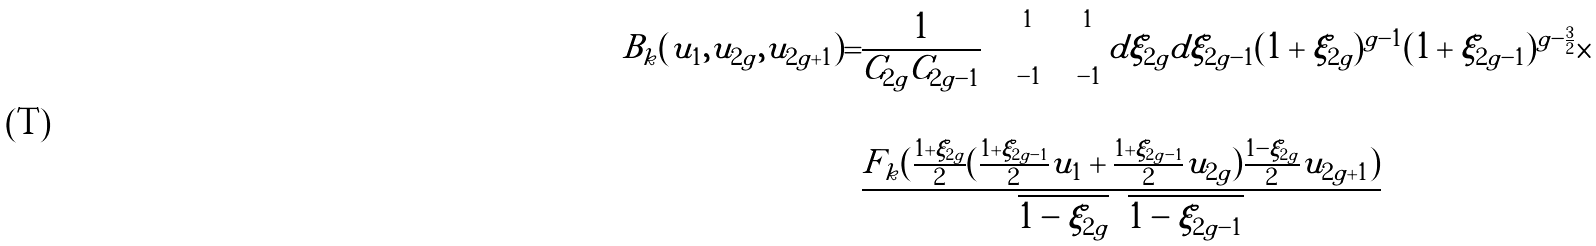<formula> <loc_0><loc_0><loc_500><loc_500>B _ { k } ( u _ { 1 } , u _ { 2 g } , u _ { 2 g + 1 } ) = & \frac { 1 } { C _ { 2 g } C _ { 2 g - 1 } } \int _ { - 1 } ^ { 1 } \int _ { - 1 } ^ { 1 } d \xi _ { 2 g } d \xi _ { 2 g - 1 } ( 1 + \xi _ { 2 g } ) ^ { g - 1 } ( 1 + \xi _ { 2 g - 1 } ) ^ { g - \frac { 3 } { 2 } } \times \\ & \\ & \frac { F _ { k } ( \frac { 1 + \xi _ { 2 g } } { 2 } ( \frac { 1 + \xi _ { 2 g - 1 } } { 2 } u _ { 1 } + \frac { 1 + \xi _ { 2 g - 1 } } { 2 } u _ { 2 g } ) \frac { 1 - \xi _ { 2 g } } { 2 } u _ { 2 g + 1 } ) } { \sqrt { 1 - \xi _ { 2 g } } \sqrt { 1 - \xi _ { 2 g - 1 } } }</formula> 